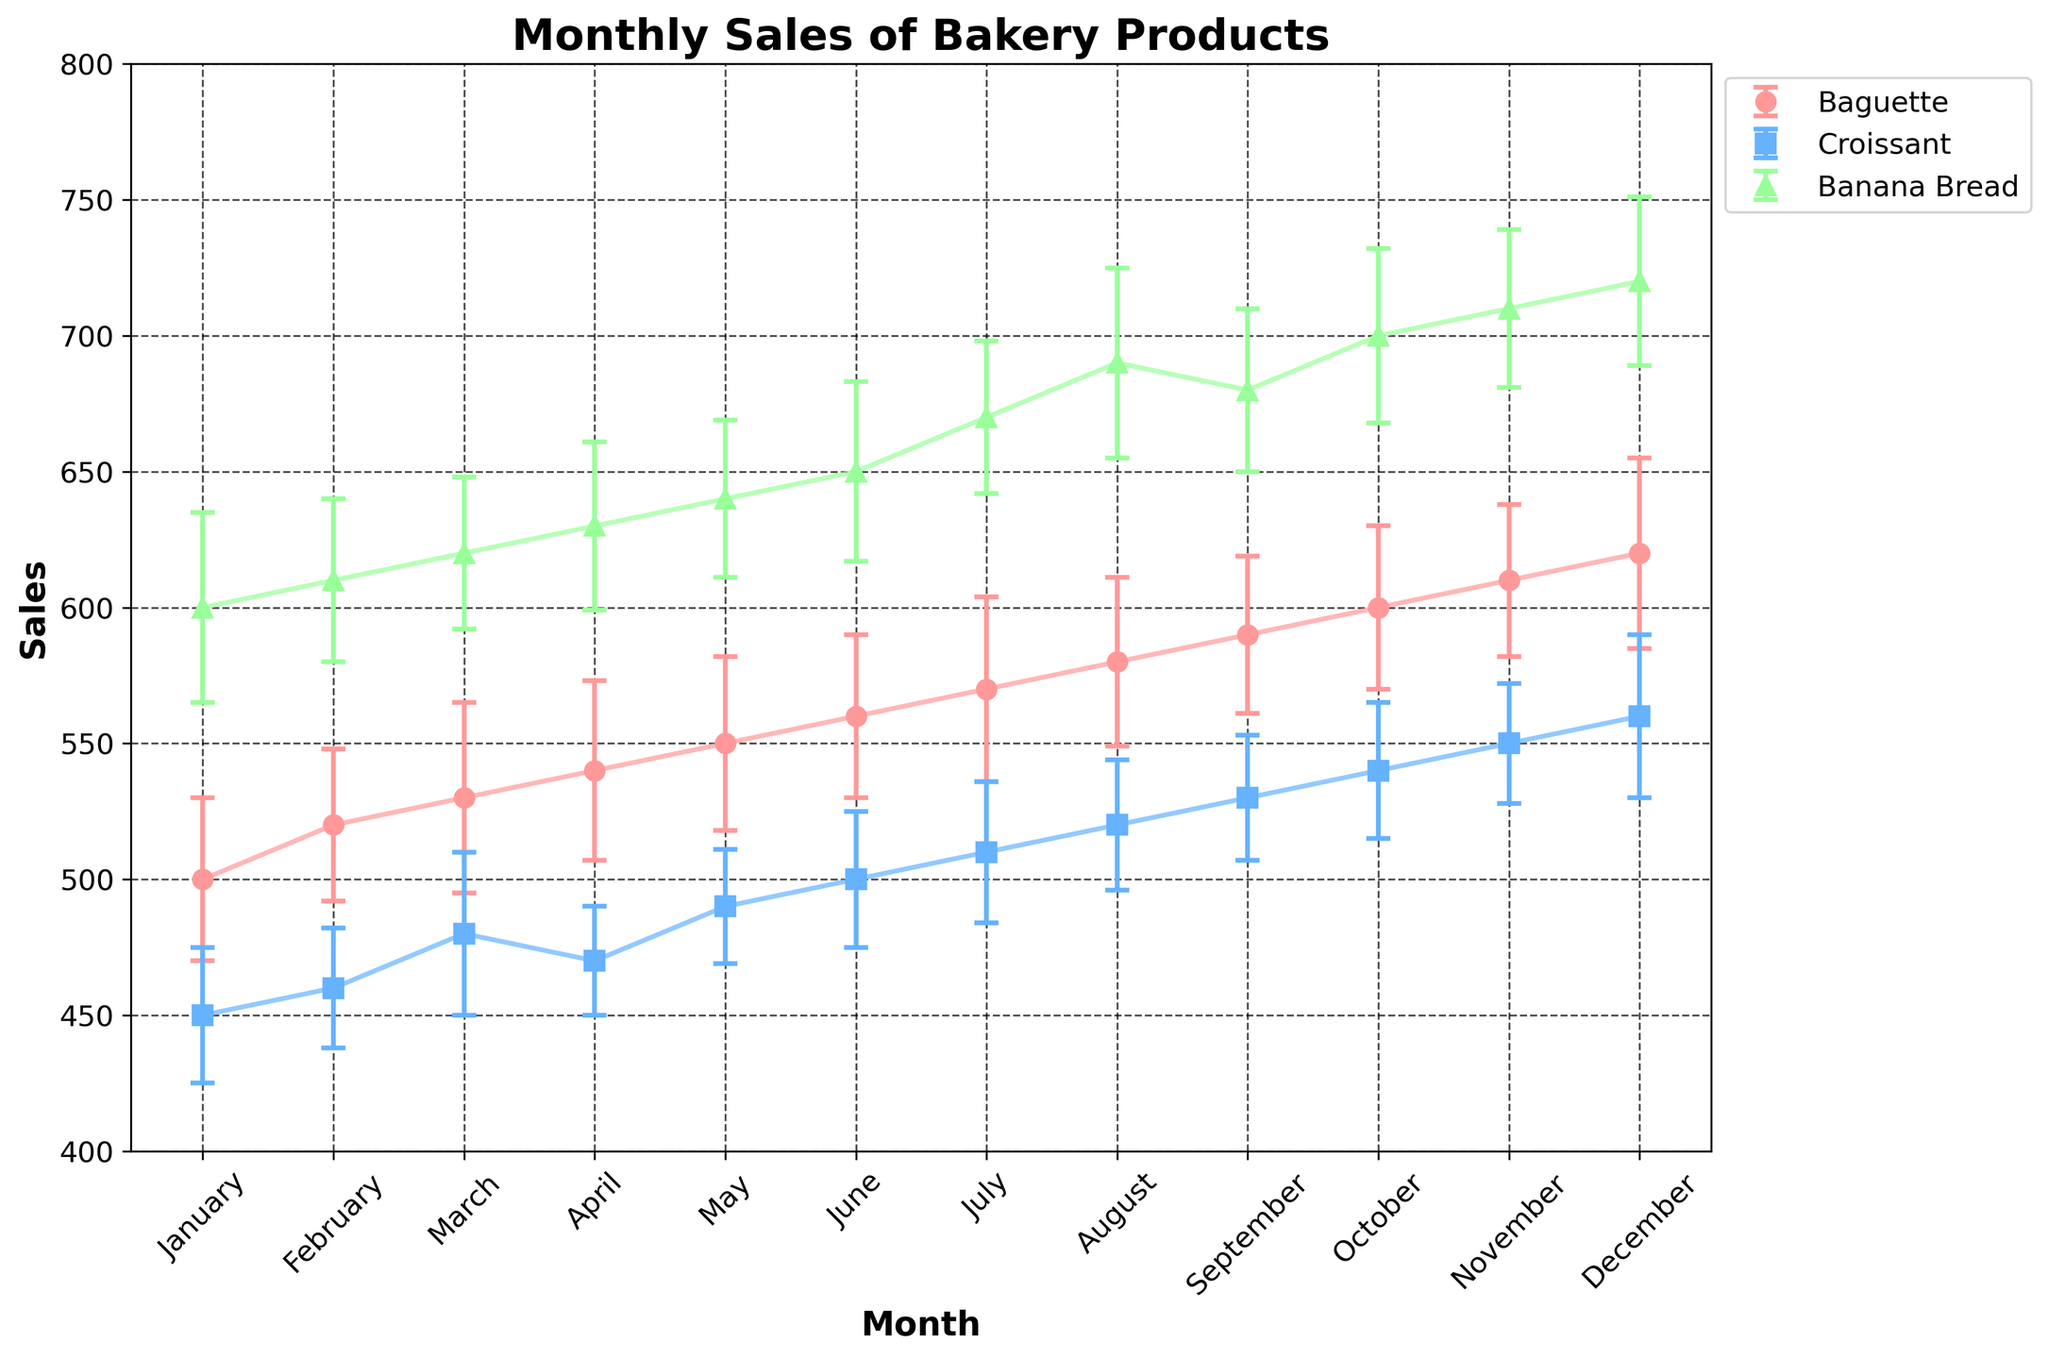what is the title of the plot? The title of the plot is located at the top center of the figure and is typically set in bold and larger font size to make it easily distinguishable.
Answer: Monthly Sales of Bakery Products what do the error bars represent in this plot? Error bars indicate the uncertainty or variability in the sales data. They provide graphical representation of the variability of data and help in understanding the reliability of the data points.
Answer: Uncertainty in sales what is the trend of Banana Bread sales from January to December? The upward trend can be observed by noting the increase in the height of the Banana Bread sales line from January to December, showing a general increase over time.
Answer: Increasing which month has the highest sales for Croissants? By identifying the highest point on the Croissant sales line plot and checking the corresponding month on the x-axis, the highest sales for Croissants is found in December.
Answer: December which product shows the highest sales in June? By comparing the heights of each product's sales line at June, Banana Bread has the highest sales as it is located above Baguette and Croissant lines.
Answer: Banana Bread what is the average sales of Baguettes over the year? To find the average sales, sum the Baguette sales data (500 + 520 + 530 + 540 + 550 + 560 + 570 + 580 + 590 + 600 + 610 + 620) and divide by 12.
Answer: 560 how does the uncertainty in Croissant sales for July compare to January? Compare the size of the error bars in July and January, noting that July's error bar is slightly larger than January's indicating greater uncertainty.
Answer: Greater in July which product has a nearly constant rate of sales growth over the months? By observing the lines' slopes, the Croissant line has a more consistent and steady slope in comparison to the other products, indicating a nearly constant growth rate over the months.
Answer: Croissants 